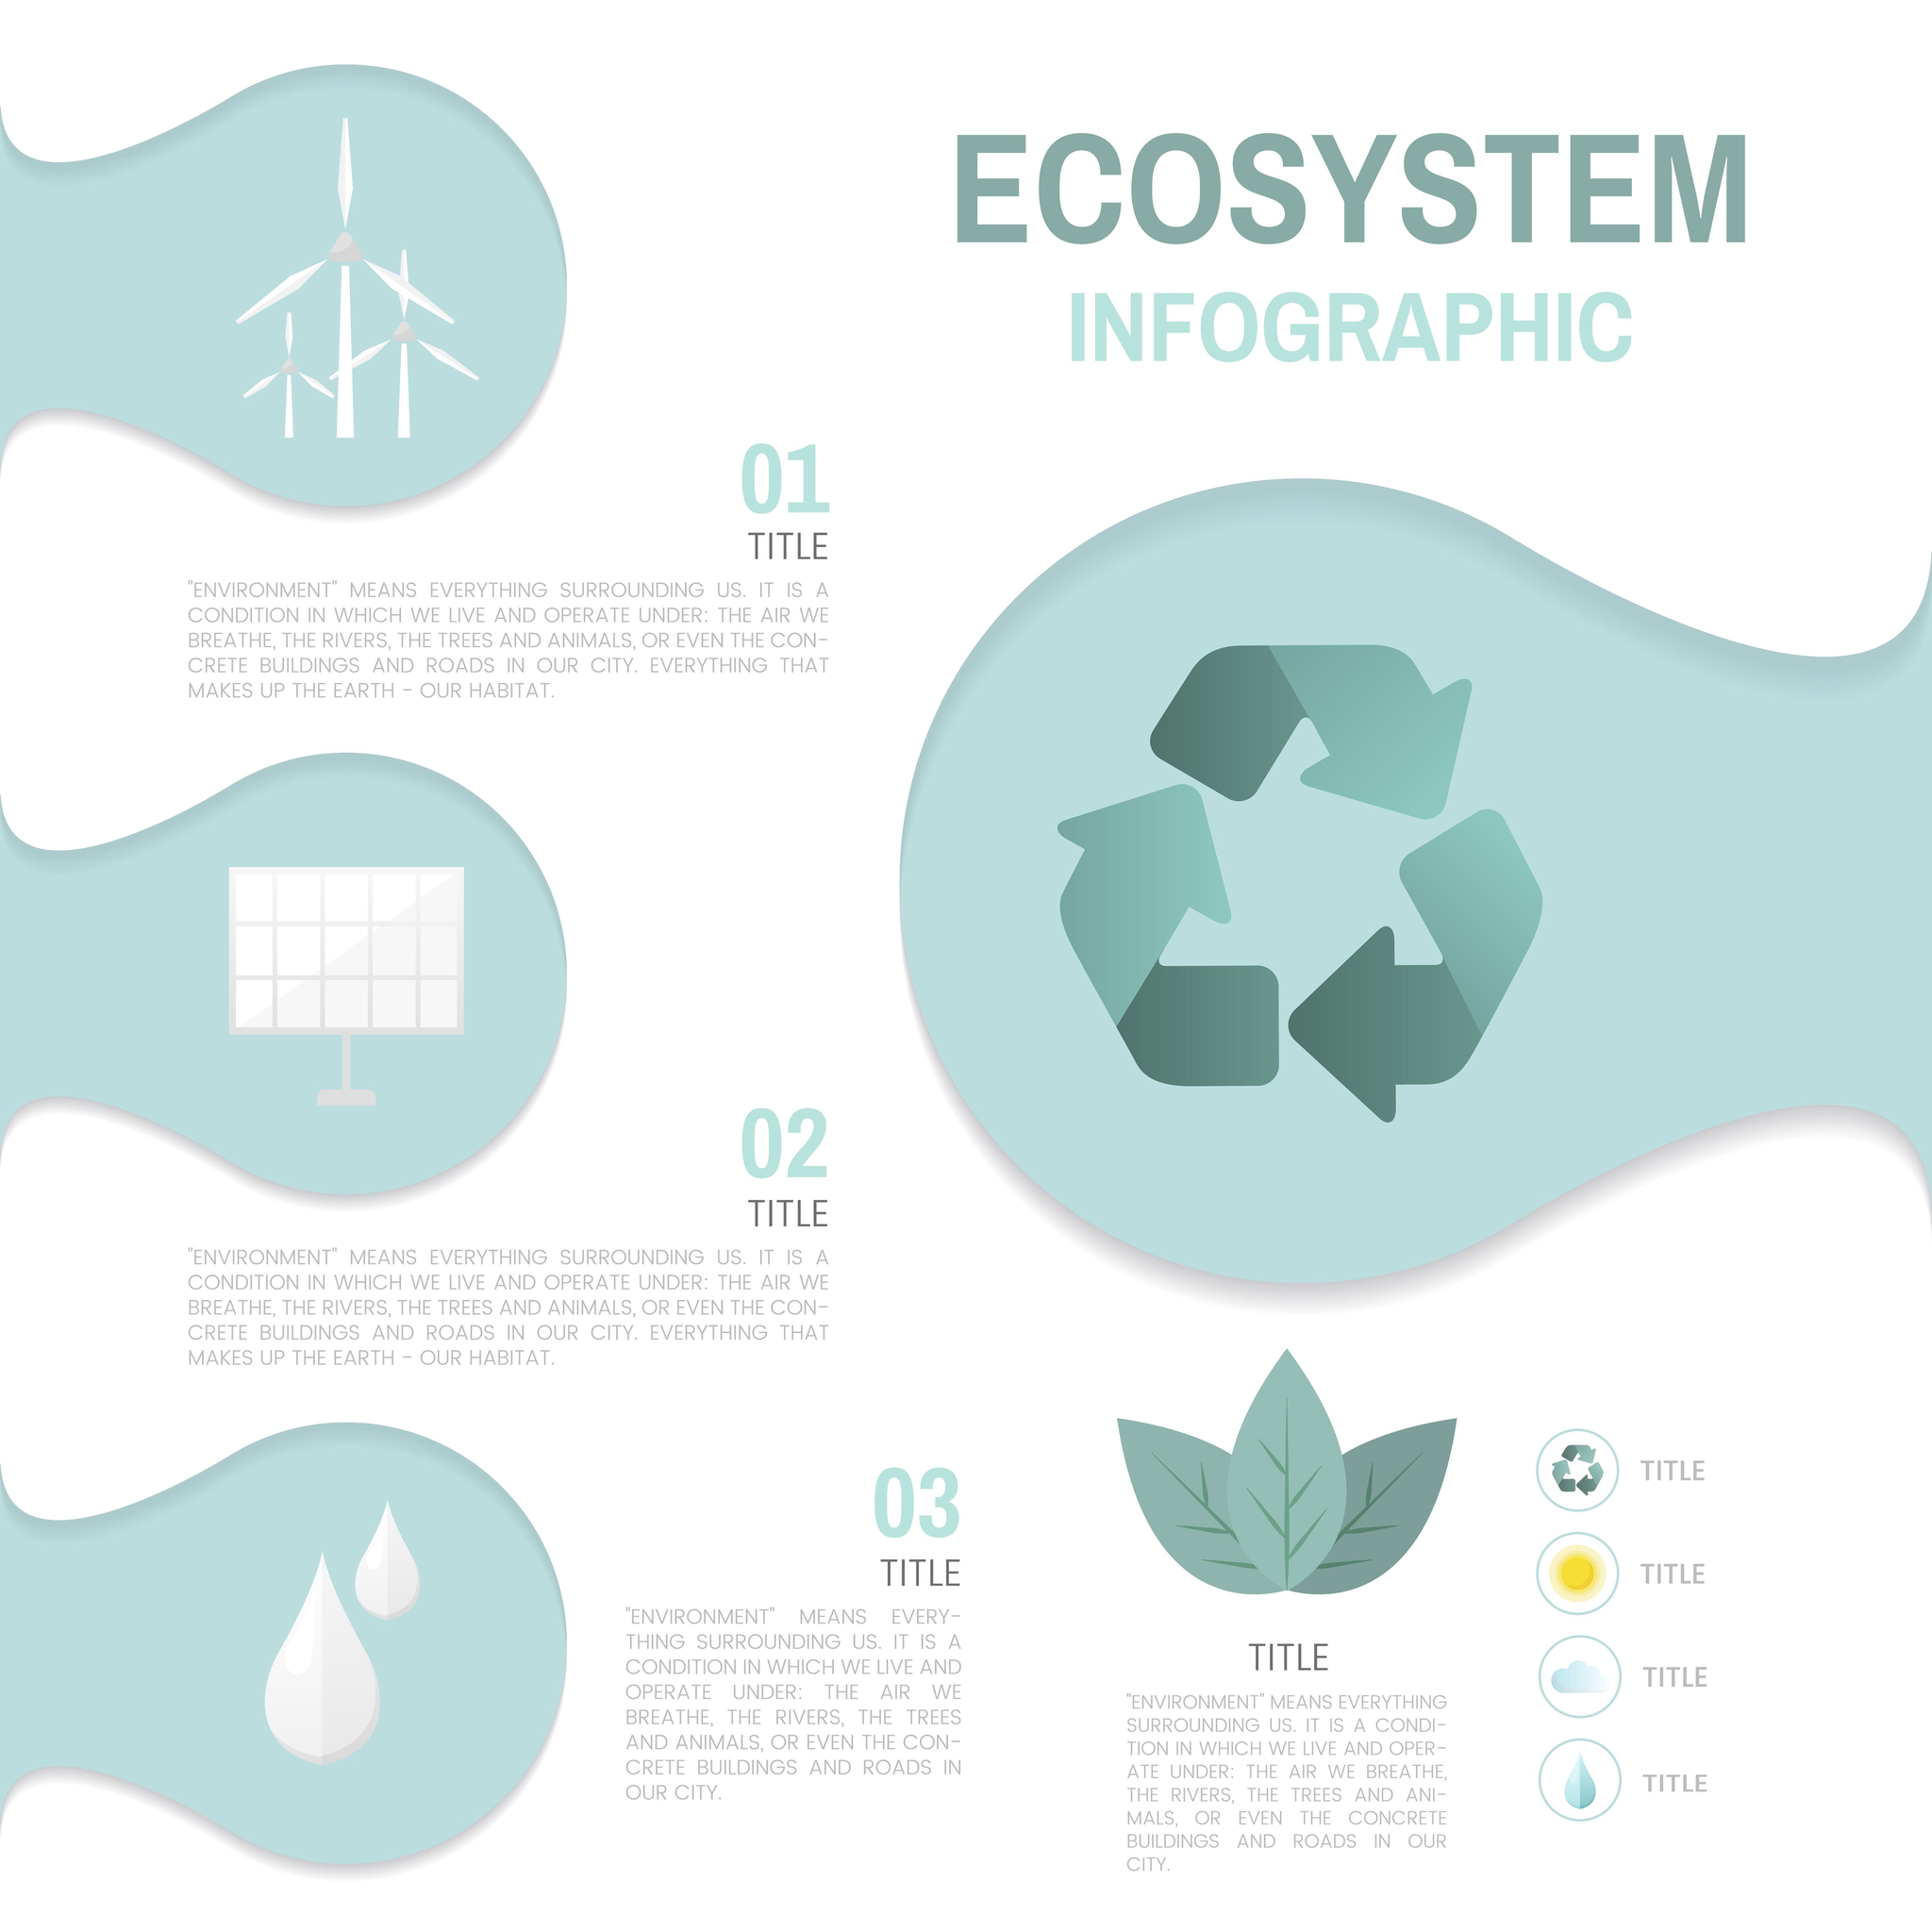Outline some significant characteristics in this image. The symbol used to represent Title 3 is represented by either the sun, water drops, or water drops," said the speaker. 